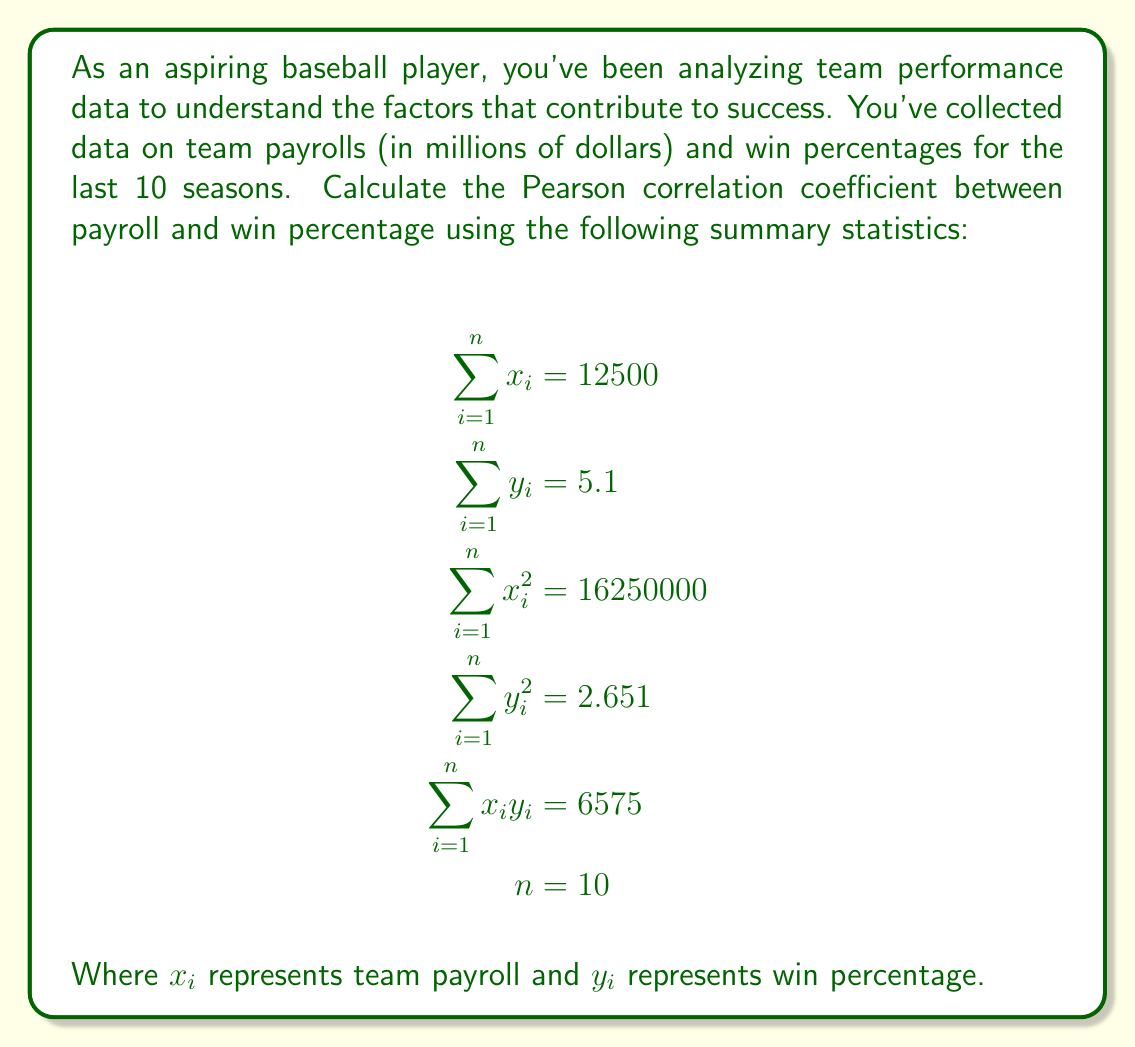Can you solve this math problem? To calculate the Pearson correlation coefficient, we'll use the formula:

$$r = \frac{n\sum x_iy_i - \sum x_i \sum y_i}{\sqrt{[n\sum x_i^2 - (\sum x_i)^2][n\sum y_i^2 - (\sum y_i)^2]}}$$

Let's calculate each component:

1) $n\sum x_iy_i = 10 \times 6575 = 65750$

2) $\sum x_i \sum y_i = 12500 \times 5.1 = 63750$

3) $n\sum x_i^2 = 10 \times 16250000 = 162500000$

4) $(\sum x_i)^2 = 12500^2 = 156250000$

5) $n\sum y_i^2 = 10 \times 2.651 = 26.51$

6) $(\sum y_i)^2 = 5.1^2 = 26.01$

Now, let's plug these values into the formula:

$$r = \frac{65750 - 63750}{\sqrt{[162500000 - 156250000][26.51 - 26.01]}}$$

$$r = \frac{2000}{\sqrt{6250000 \times 0.5}}$$

$$r = \frac{2000}{\sqrt{3125000}}$$

$$r = \frac{2000}{1768.24}$$

$$r \approx 0.1131$$

This result indicates a weak positive correlation between team payroll and win percentage.
Answer: $r \approx 0.1131$ 